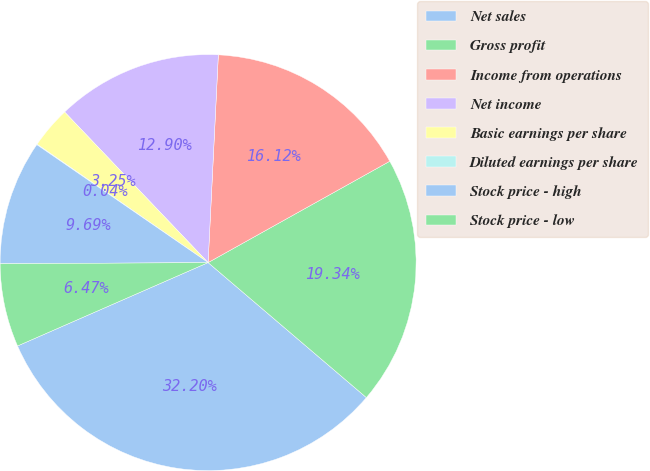Convert chart. <chart><loc_0><loc_0><loc_500><loc_500><pie_chart><fcel>Net sales<fcel>Gross profit<fcel>Income from operations<fcel>Net income<fcel>Basic earnings per share<fcel>Diluted earnings per share<fcel>Stock price - high<fcel>Stock price - low<nl><fcel>32.2%<fcel>19.34%<fcel>16.12%<fcel>12.9%<fcel>3.25%<fcel>0.04%<fcel>9.69%<fcel>6.47%<nl></chart> 